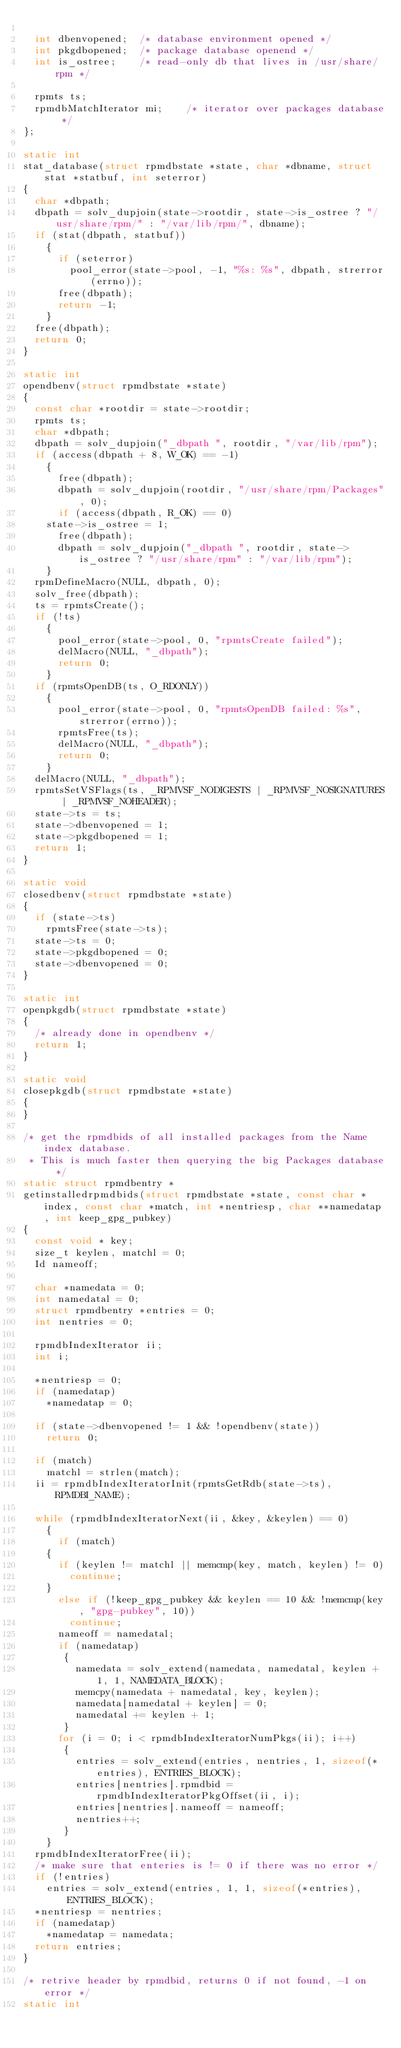Convert code to text. <code><loc_0><loc_0><loc_500><loc_500><_C_>
  int dbenvopened;	/* database environment opened */
  int pkgdbopened;	/* package database openend */
  int is_ostree;	/* read-only db that lives in /usr/share/rpm */

  rpmts ts;
  rpmdbMatchIterator mi;	/* iterator over packages database */
};

static int
stat_database(struct rpmdbstate *state, char *dbname, struct stat *statbuf, int seterror)
{
  char *dbpath;
  dbpath = solv_dupjoin(state->rootdir, state->is_ostree ? "/usr/share/rpm/" : "/var/lib/rpm/", dbname);
  if (stat(dbpath, statbuf))
    {
      if (seterror)
        pool_error(state->pool, -1, "%s: %s", dbpath, strerror(errno));
      free(dbpath);
      return -1;
    }
  free(dbpath);
  return 0;
}

static int
opendbenv(struct rpmdbstate *state)
{
  const char *rootdir = state->rootdir;
  rpmts ts;
  char *dbpath;
  dbpath = solv_dupjoin("_dbpath ", rootdir, "/var/lib/rpm");
  if (access(dbpath + 8, W_OK) == -1)
    {
      free(dbpath);
      dbpath = solv_dupjoin(rootdir, "/usr/share/rpm/Packages", 0);
      if (access(dbpath, R_OK) == 0)
	state->is_ostree = 1;
      free(dbpath);
      dbpath = solv_dupjoin("_dbpath ", rootdir, state->is_ostree ? "/usr/share/rpm" : "/var/lib/rpm");
    }
  rpmDefineMacro(NULL, dbpath, 0);
  solv_free(dbpath);
  ts = rpmtsCreate();
  if (!ts)
    {
      pool_error(state->pool, 0, "rpmtsCreate failed");
      delMacro(NULL, "_dbpath");
      return 0;
    }
  if (rpmtsOpenDB(ts, O_RDONLY))
    {
      pool_error(state->pool, 0, "rpmtsOpenDB failed: %s", strerror(errno));
      rpmtsFree(ts);
      delMacro(NULL, "_dbpath");
      return 0;
    }
  delMacro(NULL, "_dbpath");
  rpmtsSetVSFlags(ts, _RPMVSF_NODIGESTS | _RPMVSF_NOSIGNATURES | _RPMVSF_NOHEADER);
  state->ts = ts;
  state->dbenvopened = 1;
  state->pkgdbopened = 1;
  return 1;
}

static void
closedbenv(struct rpmdbstate *state)
{
  if (state->ts)
    rpmtsFree(state->ts);
  state->ts = 0;
  state->pkgdbopened = 0;
  state->dbenvopened = 0;
}

static int
openpkgdb(struct rpmdbstate *state)
{
  /* already done in opendbenv */
  return 1;
}

static void
closepkgdb(struct rpmdbstate *state)
{
}

/* get the rpmdbids of all installed packages from the Name index database.
 * This is much faster then querying the big Packages database */
static struct rpmdbentry *
getinstalledrpmdbids(struct rpmdbstate *state, const char *index, const char *match, int *nentriesp, char **namedatap, int keep_gpg_pubkey)
{
  const void * key;
  size_t keylen, matchl = 0;
  Id nameoff;

  char *namedata = 0;
  int namedatal = 0;
  struct rpmdbentry *entries = 0;
  int nentries = 0;

  rpmdbIndexIterator ii;
  int i;

  *nentriesp = 0;
  if (namedatap)
    *namedatap = 0;

  if (state->dbenvopened != 1 && !opendbenv(state))
    return 0;

  if (match)
    matchl = strlen(match);
  ii = rpmdbIndexIteratorInit(rpmtsGetRdb(state->ts), RPMDBI_NAME);

  while (rpmdbIndexIteratorNext(ii, &key, &keylen) == 0)
    {
      if (match)
	{
	  if (keylen != matchl || memcmp(key, match, keylen) != 0)
	    continue;
	}
      else if (!keep_gpg_pubkey && keylen == 10 && !memcmp(key, "gpg-pubkey", 10))
        continue;
      nameoff = namedatal;
      if (namedatap)
       {
         namedata = solv_extend(namedata, namedatal, keylen + 1, 1, NAMEDATA_BLOCK);
         memcpy(namedata + namedatal, key, keylen);
         namedata[namedatal + keylen] = 0;
         namedatal += keylen + 1;
       }
      for (i = 0; i < rpmdbIndexIteratorNumPkgs(ii); i++)
       {
         entries = solv_extend(entries, nentries, 1, sizeof(*entries), ENTRIES_BLOCK);
         entries[nentries].rpmdbid = rpmdbIndexIteratorPkgOffset(ii, i);
         entries[nentries].nameoff = nameoff;
         nentries++;
       }
    }
  rpmdbIndexIteratorFree(ii);
  /* make sure that enteries is != 0 if there was no error */
  if (!entries)
    entries = solv_extend(entries, 1, 1, sizeof(*entries), ENTRIES_BLOCK);
  *nentriesp = nentries;
  if (namedatap)
    *namedatap = namedata;
  return entries;
}

/* retrive header by rpmdbid, returns 0 if not found, -1 on error */
static int</code> 